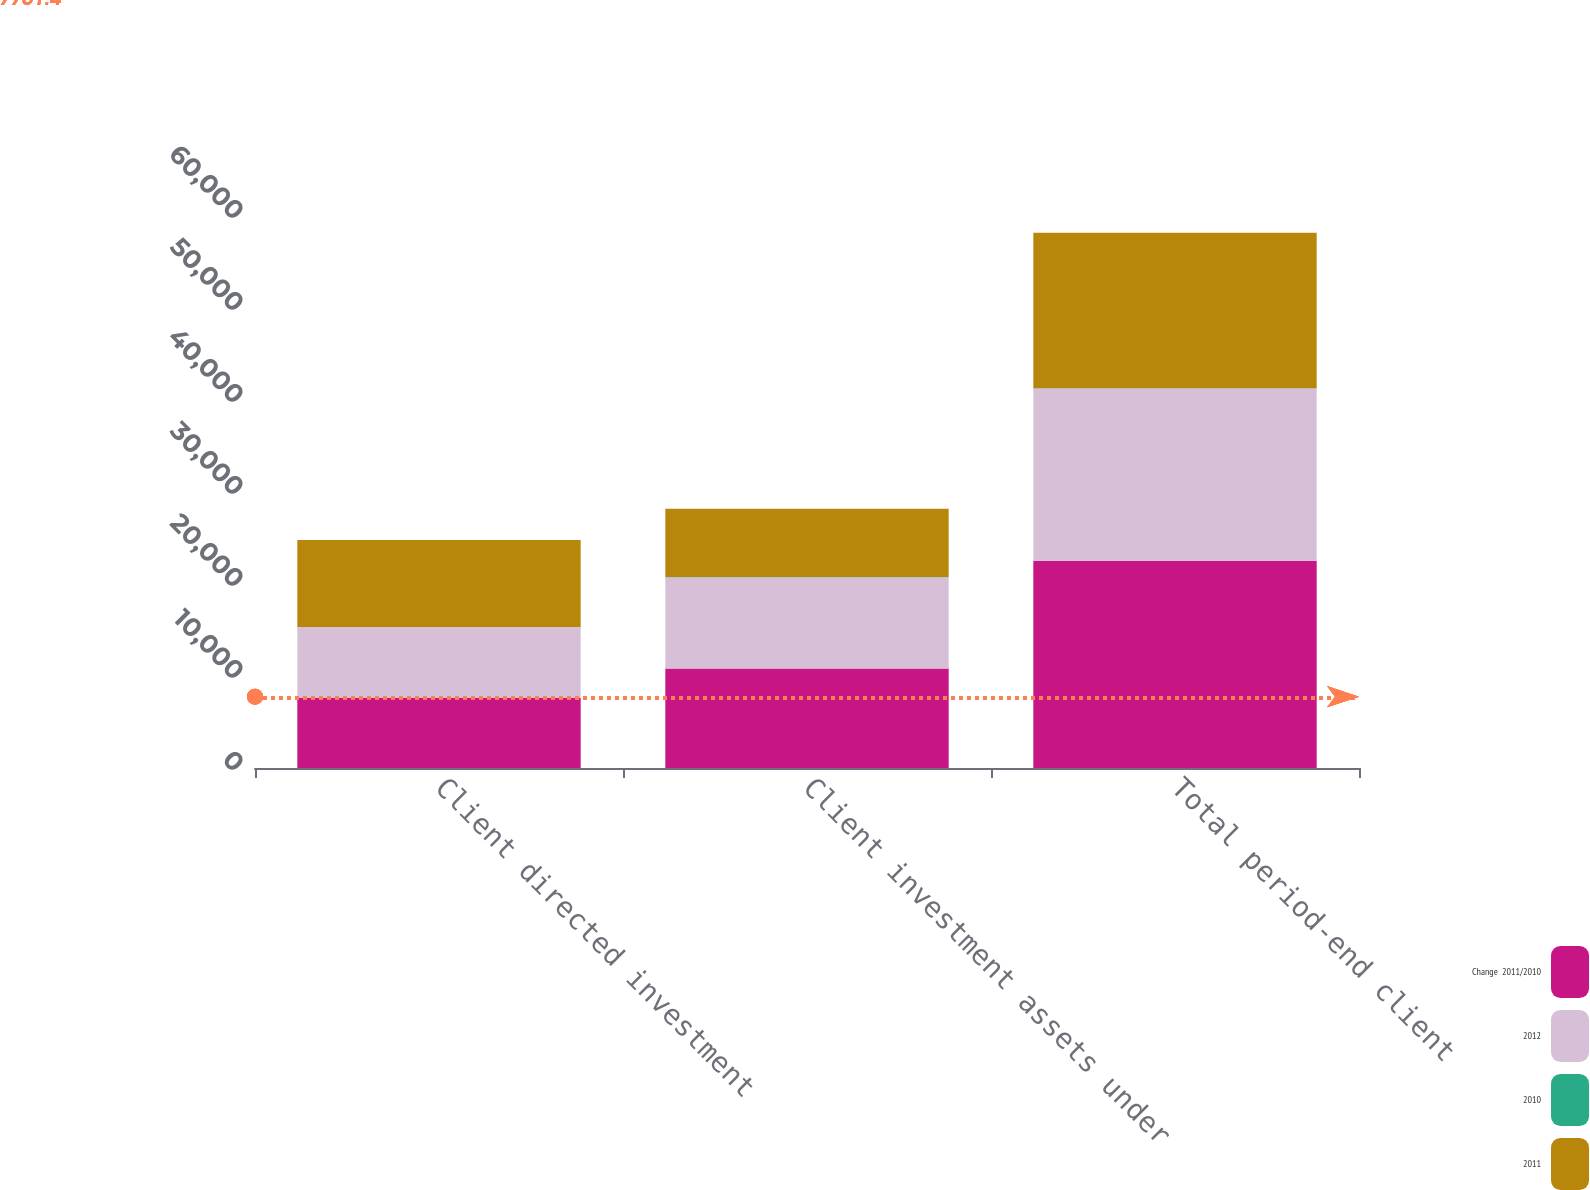<chart> <loc_0><loc_0><loc_500><loc_500><stacked_bar_chart><ecel><fcel>Client directed investment<fcel>Client investment assets under<fcel>Total period-end client<nl><fcel>Change  2011/2010<fcel>7604<fcel>10824<fcel>22513<nl><fcel>2012<fcel>7709<fcel>9919<fcel>18744<nl><fcel>2010<fcel>1.4<fcel>9.1<fcel>20.1<nl><fcel>2011<fcel>9479<fcel>7415<fcel>16894<nl></chart> 